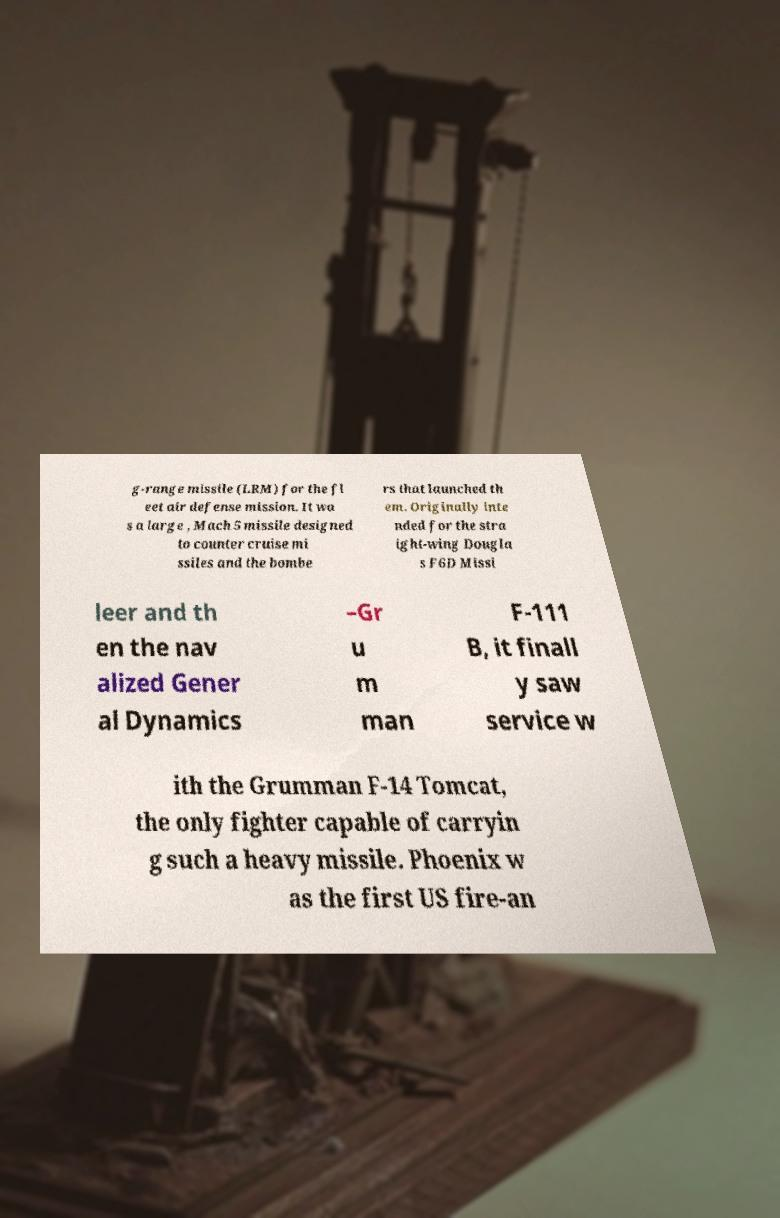What messages or text are displayed in this image? I need them in a readable, typed format. g-range missile (LRM) for the fl eet air defense mission. It wa s a large , Mach 5 missile designed to counter cruise mi ssiles and the bombe rs that launched th em. Originally inte nded for the stra ight-wing Dougla s F6D Missi leer and th en the nav alized Gener al Dynamics –Gr u m man F-111 B, it finall y saw service w ith the Grumman F-14 Tomcat, the only fighter capable of carryin g such a heavy missile. Phoenix w as the first US fire-an 